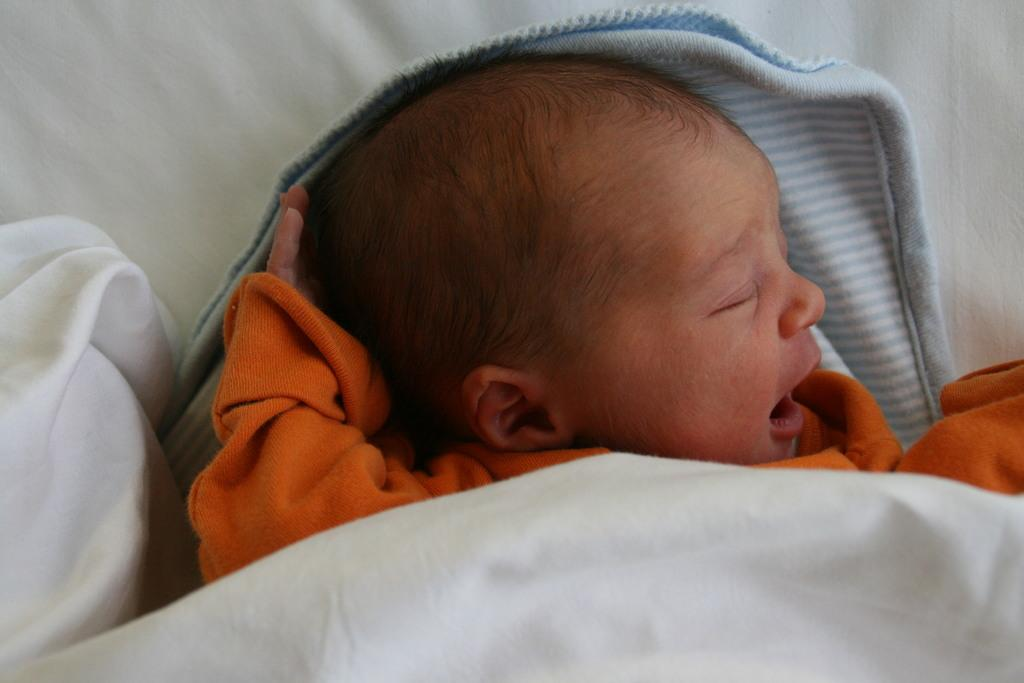What is the main subject of the image? There is a baby in the image. What color are the clothes the baby is wearing? The baby is wearing orange color clothes. Are there any other clothes visible in the image? Yes, there are white color clothes and other color clothes in the image. What type of journey is the baby taking in the image? There is no indication of a journey in the image; it simply shows a baby wearing orange clothes and surrounded by other clothes. What type of skin condition does the baby have in the image? There is no information about the baby's skin condition in the image. 